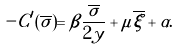Convert formula to latex. <formula><loc_0><loc_0><loc_500><loc_500>- C ^ { \prime } ( \overline { \sigma } ) = \beta \frac { \overline { \sigma } } { 2 y } + \mu \overline { \xi } + \alpha .</formula> 